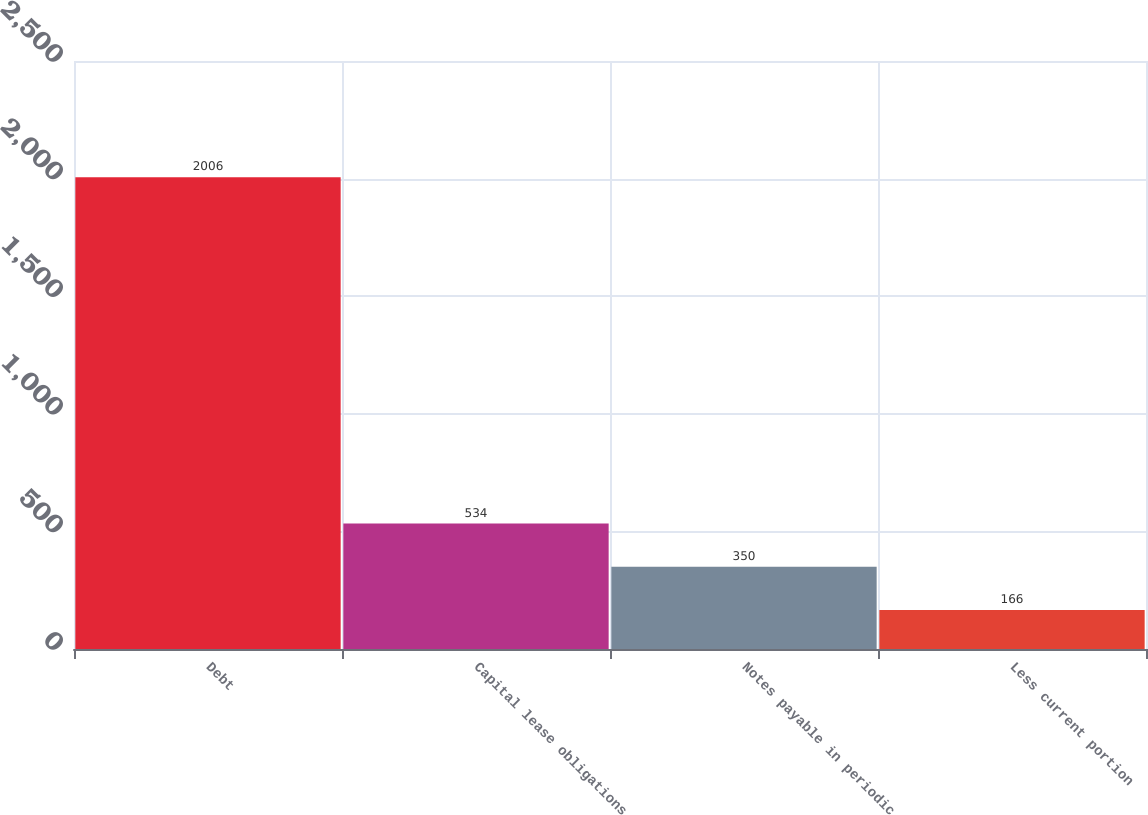<chart> <loc_0><loc_0><loc_500><loc_500><bar_chart><fcel>Debt<fcel>Capital lease obligations<fcel>Notes payable in periodic<fcel>Less current portion<nl><fcel>2006<fcel>534<fcel>350<fcel>166<nl></chart> 